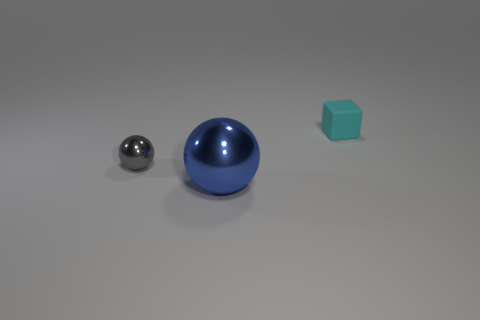Add 2 tiny gray balls. How many objects exist? 5 Subtract all spheres. How many objects are left? 1 Subtract 0 green cubes. How many objects are left? 3 Subtract all big objects. Subtract all tiny metallic blocks. How many objects are left? 2 Add 2 cyan blocks. How many cyan blocks are left? 3 Add 3 gray metallic objects. How many gray metallic objects exist? 4 